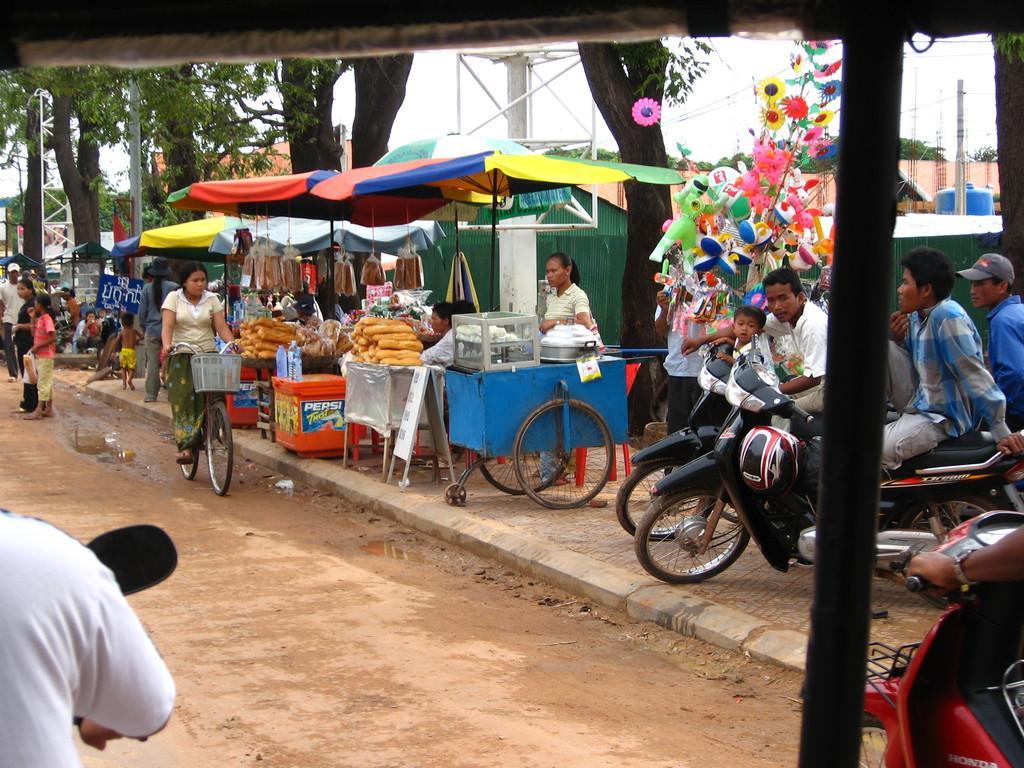In one or two sentences, can you explain what this image depicts? There are people and we can see vehicles. There is a woman riding bicycle and we can see stalls and toys. In the background we can see trees,poles and sky. 